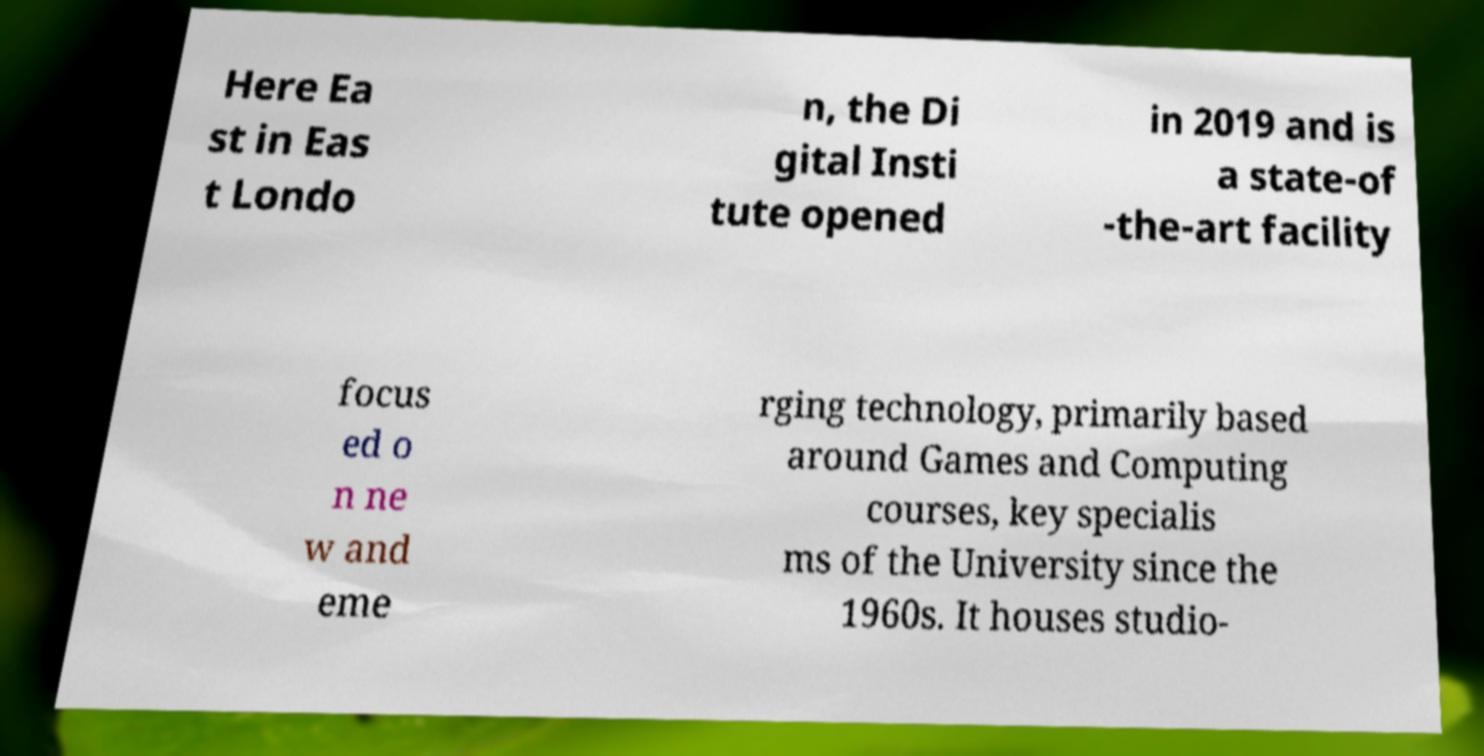I need the written content from this picture converted into text. Can you do that? Here Ea st in Eas t Londo n, the Di gital Insti tute opened in 2019 and is a state-of -the-art facility focus ed o n ne w and eme rging technology, primarily based around Games and Computing courses, key specialis ms of the University since the 1960s. It houses studio- 